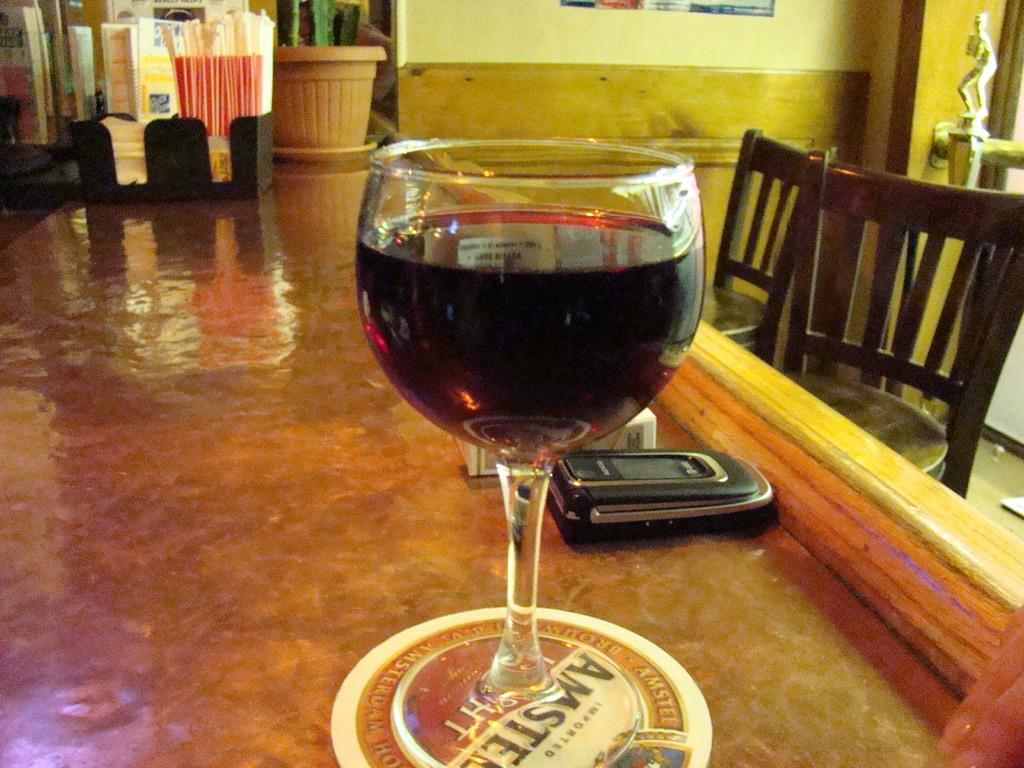What piece of furniture is in the image? There is a table in the image. What is placed on the table? A glass and a phone are present on the table. Where are the chairs located in the image? The chairs are on the right side of the image. What can be seen at the top of the image? There is a plant at the top of the image. What type of straw is being used by the army in the image? There is no army or straw present in the image. What government policy is being discussed in the image? There is no discussion of government policy in the image. 